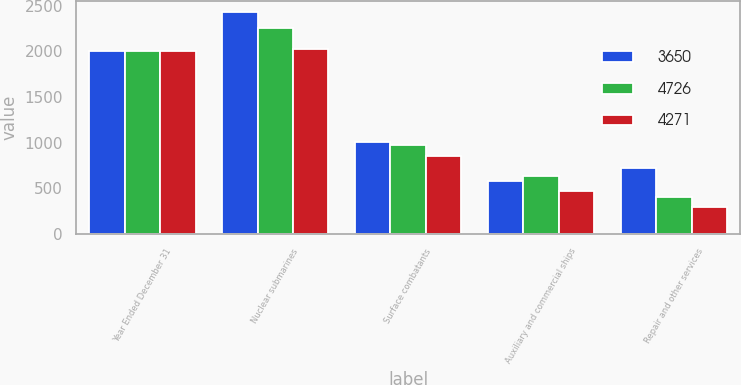Convert chart. <chart><loc_0><loc_0><loc_500><loc_500><stacked_bar_chart><ecel><fcel>Year Ended December 31<fcel>Nuclear submarines<fcel>Surface combatants<fcel>Auxiliary and commercial ships<fcel>Repair and other services<nl><fcel>3650<fcel>2004<fcel>2432<fcel>1002<fcel>576<fcel>716<nl><fcel>4726<fcel>2003<fcel>2256<fcel>973<fcel>638<fcel>404<nl><fcel>4271<fcel>2002<fcel>2030<fcel>852<fcel>471<fcel>297<nl></chart> 